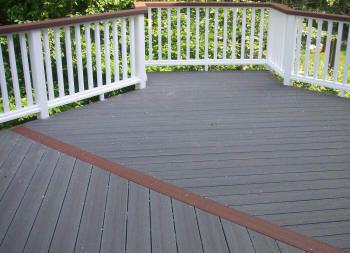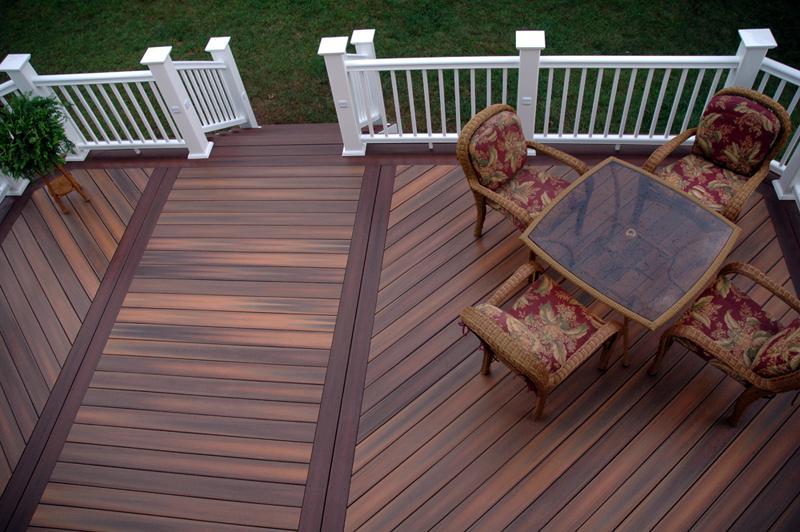The first image is the image on the left, the second image is the image on the right. Analyze the images presented: Is the assertion "A table and 4 chairs sits on a wooden deck with a white banister." valid? Answer yes or no. Yes. The first image is the image on the left, the second image is the image on the right. Analyze the images presented: Is the assertion "One deck has dark grey flooring with no furniture on it, and the other deck has brown stained flooring, white rails, and furniture including a table with four chairs." valid? Answer yes or no. Yes. 